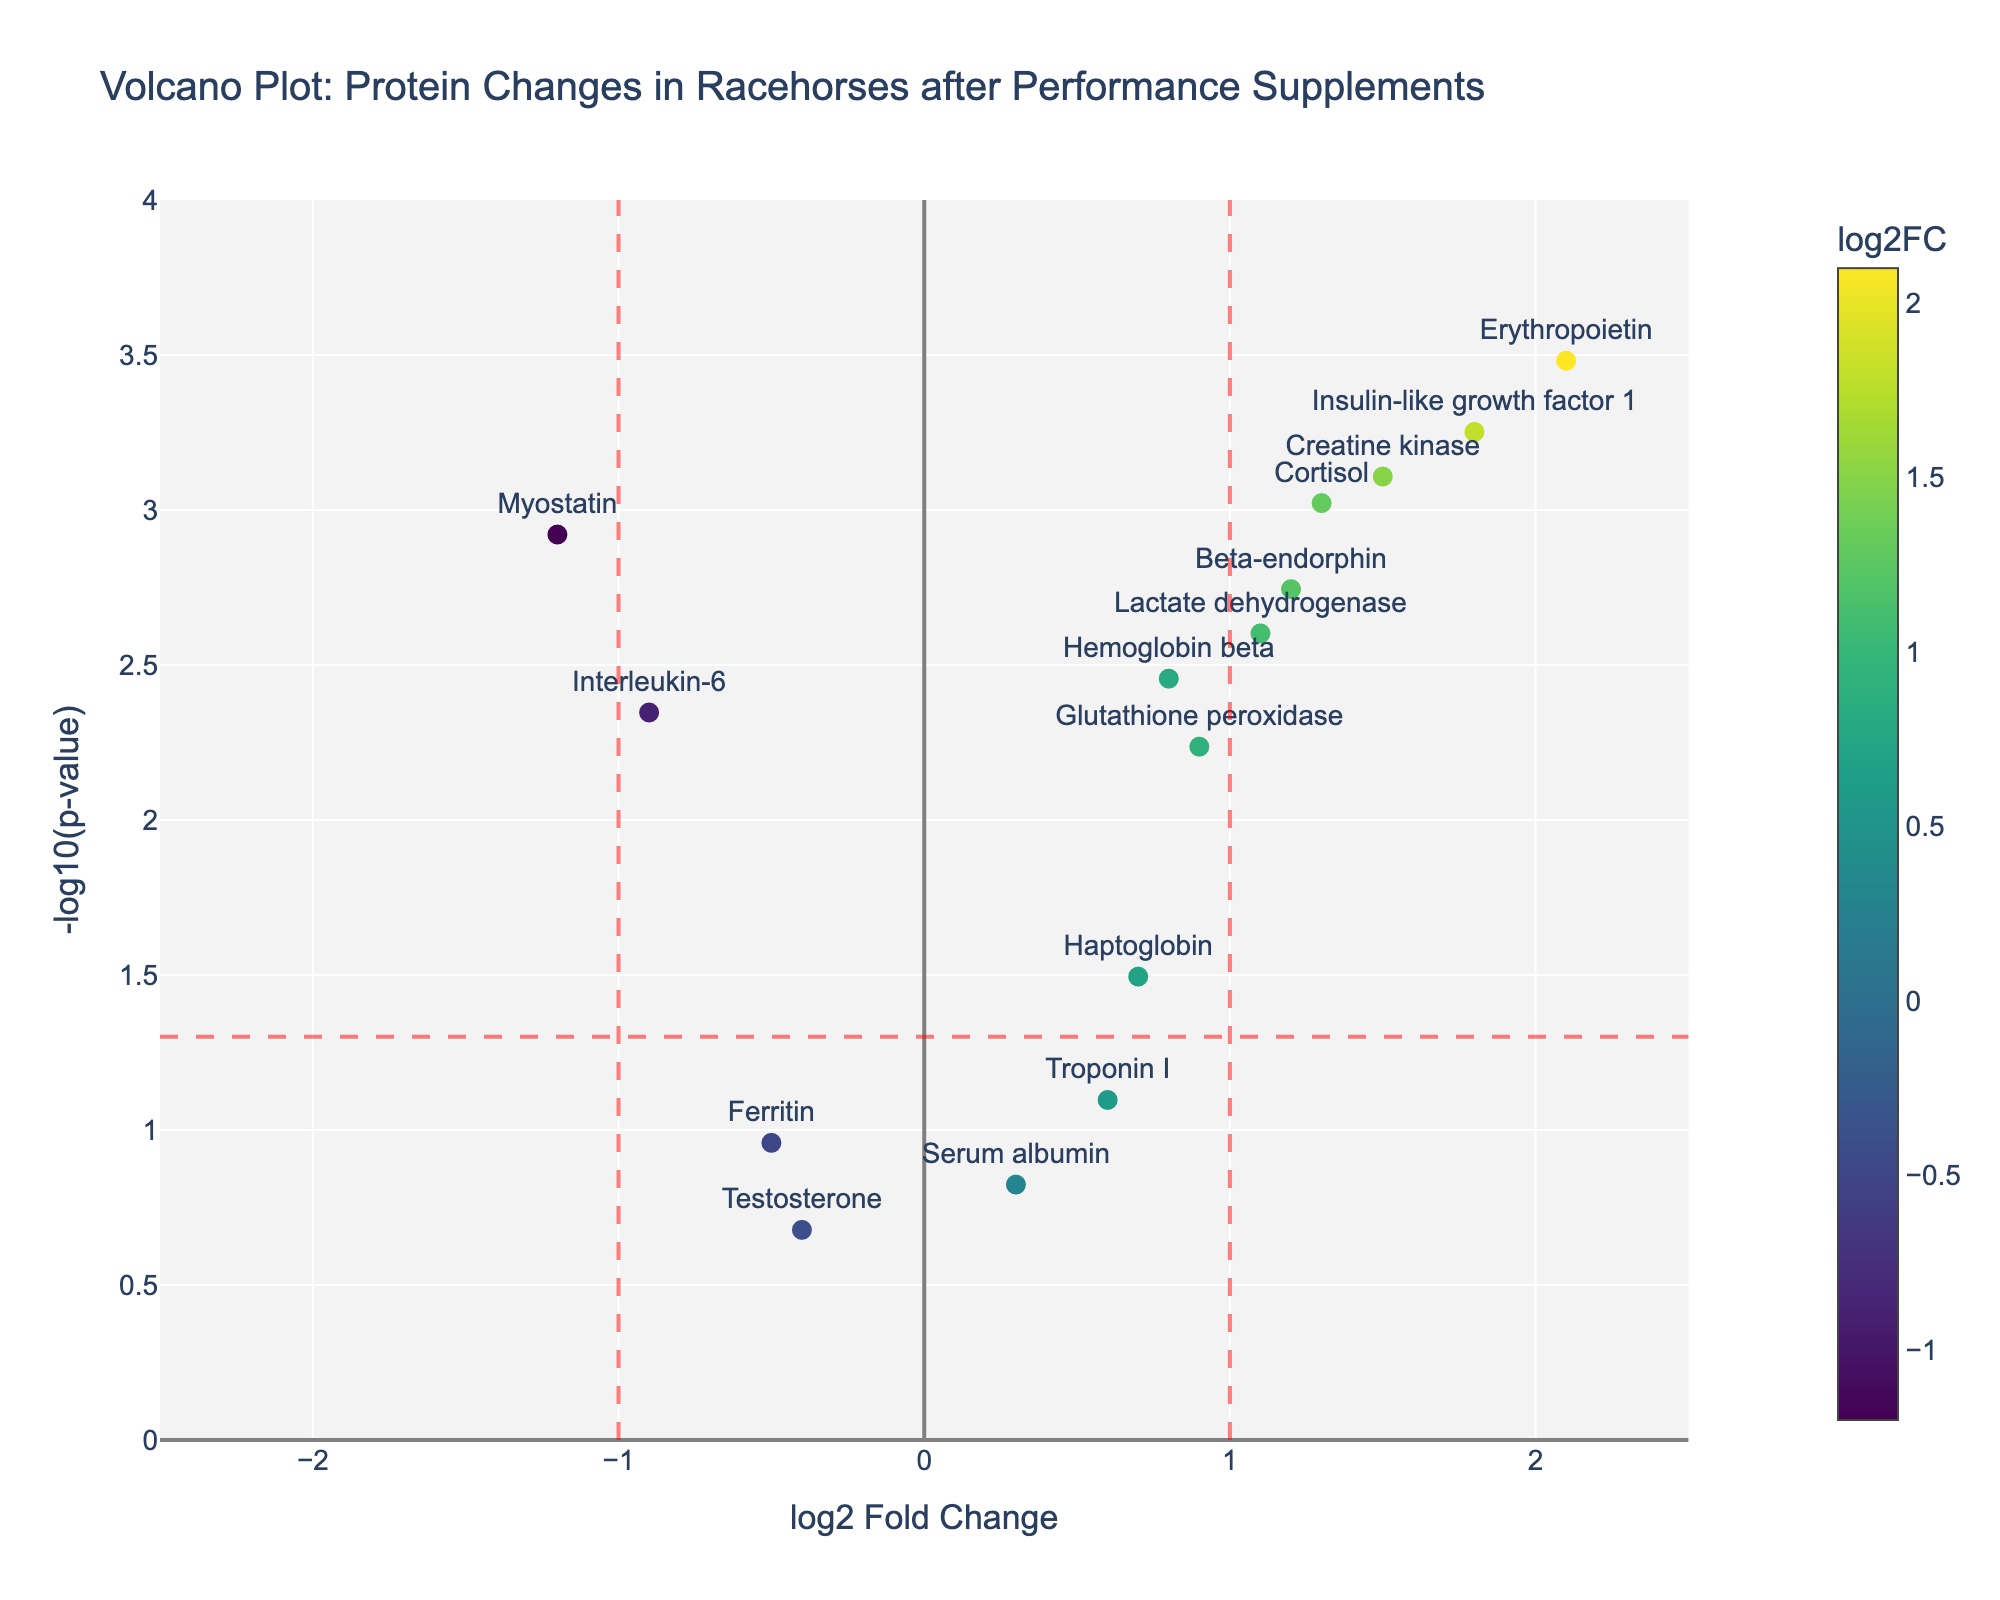1. What is the title of the plot? The title of the plot is displayed at the top of the figure.
Answer: Volcano Plot: Protein Changes in Racehorses after Performance Supplements 2. How many proteins have a log2 fold change greater than 1? Value locations above 1 on the x-axis are considered, and data points (or markers) in that region are counted.
Answer: 5 3. Which protein has the highest log2 fold change? Look for the data point furthest to the right on the x-axis representing the log2 fold change.
Answer: Erythropoietin 4. What is the significance threshold indicated by the horizontal red dashed line? The horizontal red dashed line represents the threshold of -log10(p-value). The p-value threshold is typically 0.05, so convert p-value to -log10(p-value)
Answer: -log10(0.05) = 1.3 5. Which protein has the lowest p-value, and what is its log2 fold change? Identify the data point highest on the y-axis for lowest p-value, then check its x-axis position for log2 fold change.
Answer: Erythropoietin, 2.1 6. How many proteins are significantly upregulated (log2 fold change > 1 and p-value < 0.05)? Count markers to the right of the vertical line at x=1 and above the horizontal line at y=-log10(0.05).
Answer: 4 7. Compare the log2 fold changes of Myostatin and Insulin-like Growth Factor 1. Which one has a higher change? Locate both proteins on the x-axis and compare their positions.
Answer: Insulin-like Growth Factor 1 8. Which protein has a similar log2 fold change to Hemoglobin beta but has a higher significance? Find data points close to Hemoglobin beta on the x-axis (0.8) and compare their y-axis positions.
Answer: Glutathione peroxidase 9. Are there any proteins that have a p-value greater than 0.05 and a log2 fold change of more than 1? Evaluate markers outside the horizontal line and to the right of the vertical 1 line.
Answer: No 10. What does the color of the markers represent in the plot? The color gradient shown in the color bar corresponds to the log2 fold change values of the proteins.
Answer: log2 Fold Change 